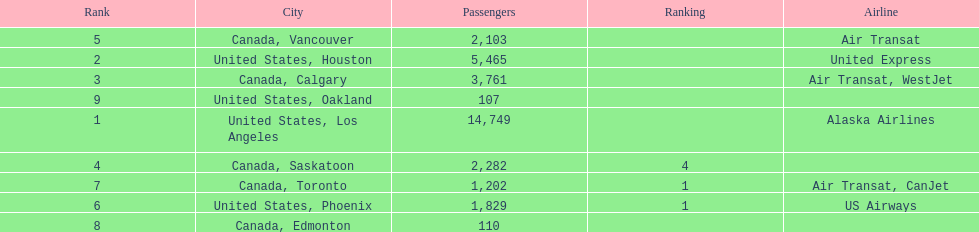Was los angeles or houston the busiest international route at manzanillo international airport in 2013? Los Angeles. 